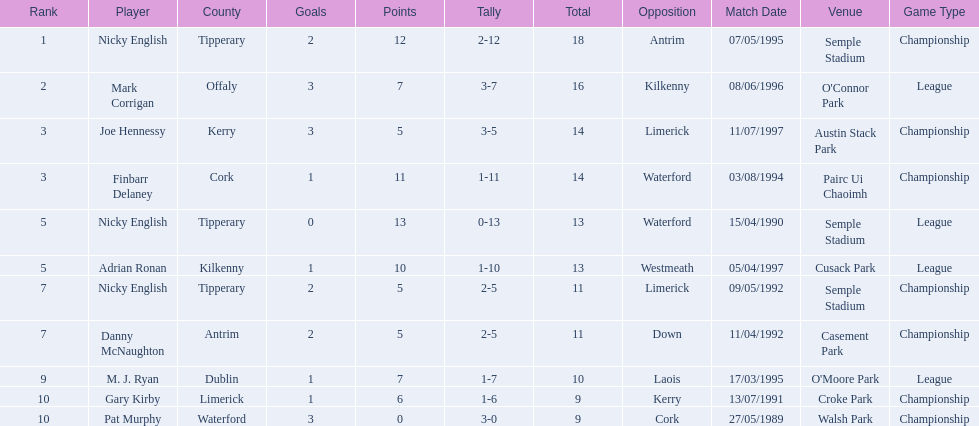Who are all the players? Nicky English, Mark Corrigan, Joe Hennessy, Finbarr Delaney, Nicky English, Adrian Ronan, Nicky English, Danny McNaughton, M. J. Ryan, Gary Kirby, Pat Murphy. How many points did they receive? 18, 16, 14, 14, 13, 13, 11, 11, 10, 9, 9. And which player received 10 points? M. J. Ryan. 